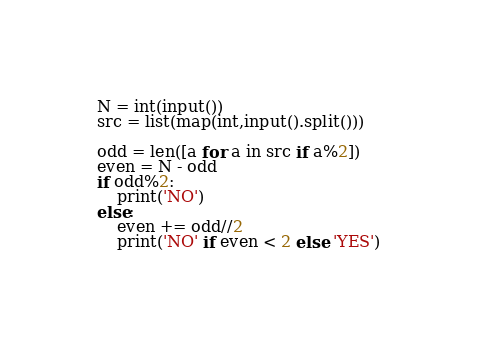<code> <loc_0><loc_0><loc_500><loc_500><_Python_>N = int(input())
src = list(map(int,input().split()))

odd = len([a for a in src if a%2])
even = N - odd
if odd%2:
    print('NO')
else:
    even += odd//2
    print('NO' if even < 2 else 'YES')</code> 